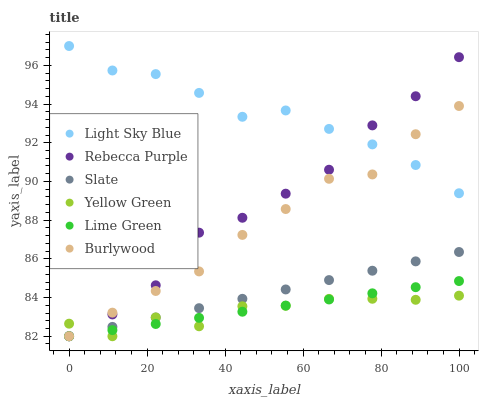Does Yellow Green have the minimum area under the curve?
Answer yes or no. Yes. Does Light Sky Blue have the maximum area under the curve?
Answer yes or no. Yes. Does Burlywood have the minimum area under the curve?
Answer yes or no. No. Does Burlywood have the maximum area under the curve?
Answer yes or no. No. Is Lime Green the smoothest?
Answer yes or no. Yes. Is Yellow Green the roughest?
Answer yes or no. Yes. Is Burlywood the smoothest?
Answer yes or no. No. Is Burlywood the roughest?
Answer yes or no. No. Does Yellow Green have the lowest value?
Answer yes or no. Yes. Does Light Sky Blue have the lowest value?
Answer yes or no. No. Does Light Sky Blue have the highest value?
Answer yes or no. Yes. Does Burlywood have the highest value?
Answer yes or no. No. Is Yellow Green less than Light Sky Blue?
Answer yes or no. Yes. Is Light Sky Blue greater than Lime Green?
Answer yes or no. Yes. Does Light Sky Blue intersect Rebecca Purple?
Answer yes or no. Yes. Is Light Sky Blue less than Rebecca Purple?
Answer yes or no. No. Is Light Sky Blue greater than Rebecca Purple?
Answer yes or no. No. Does Yellow Green intersect Light Sky Blue?
Answer yes or no. No. 